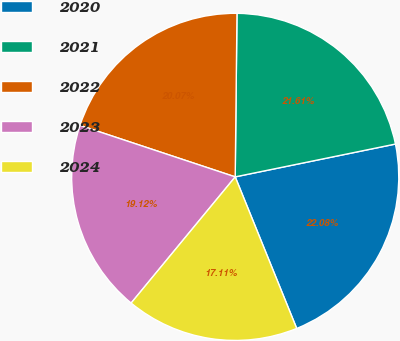Convert chart to OTSL. <chart><loc_0><loc_0><loc_500><loc_500><pie_chart><fcel>2020<fcel>2021<fcel>2022<fcel>2023<fcel>2024<nl><fcel>22.08%<fcel>21.61%<fcel>20.07%<fcel>19.12%<fcel>17.11%<nl></chart> 